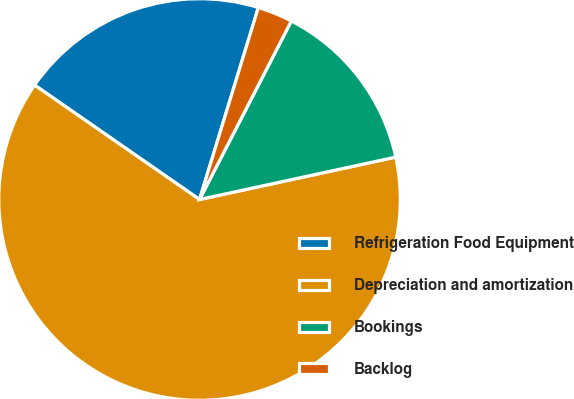Convert chart. <chart><loc_0><loc_0><loc_500><loc_500><pie_chart><fcel>Refrigeration Food Equipment<fcel>Depreciation and amortization<fcel>Bookings<fcel>Backlog<nl><fcel>20.08%<fcel>63.04%<fcel>14.05%<fcel>2.83%<nl></chart> 